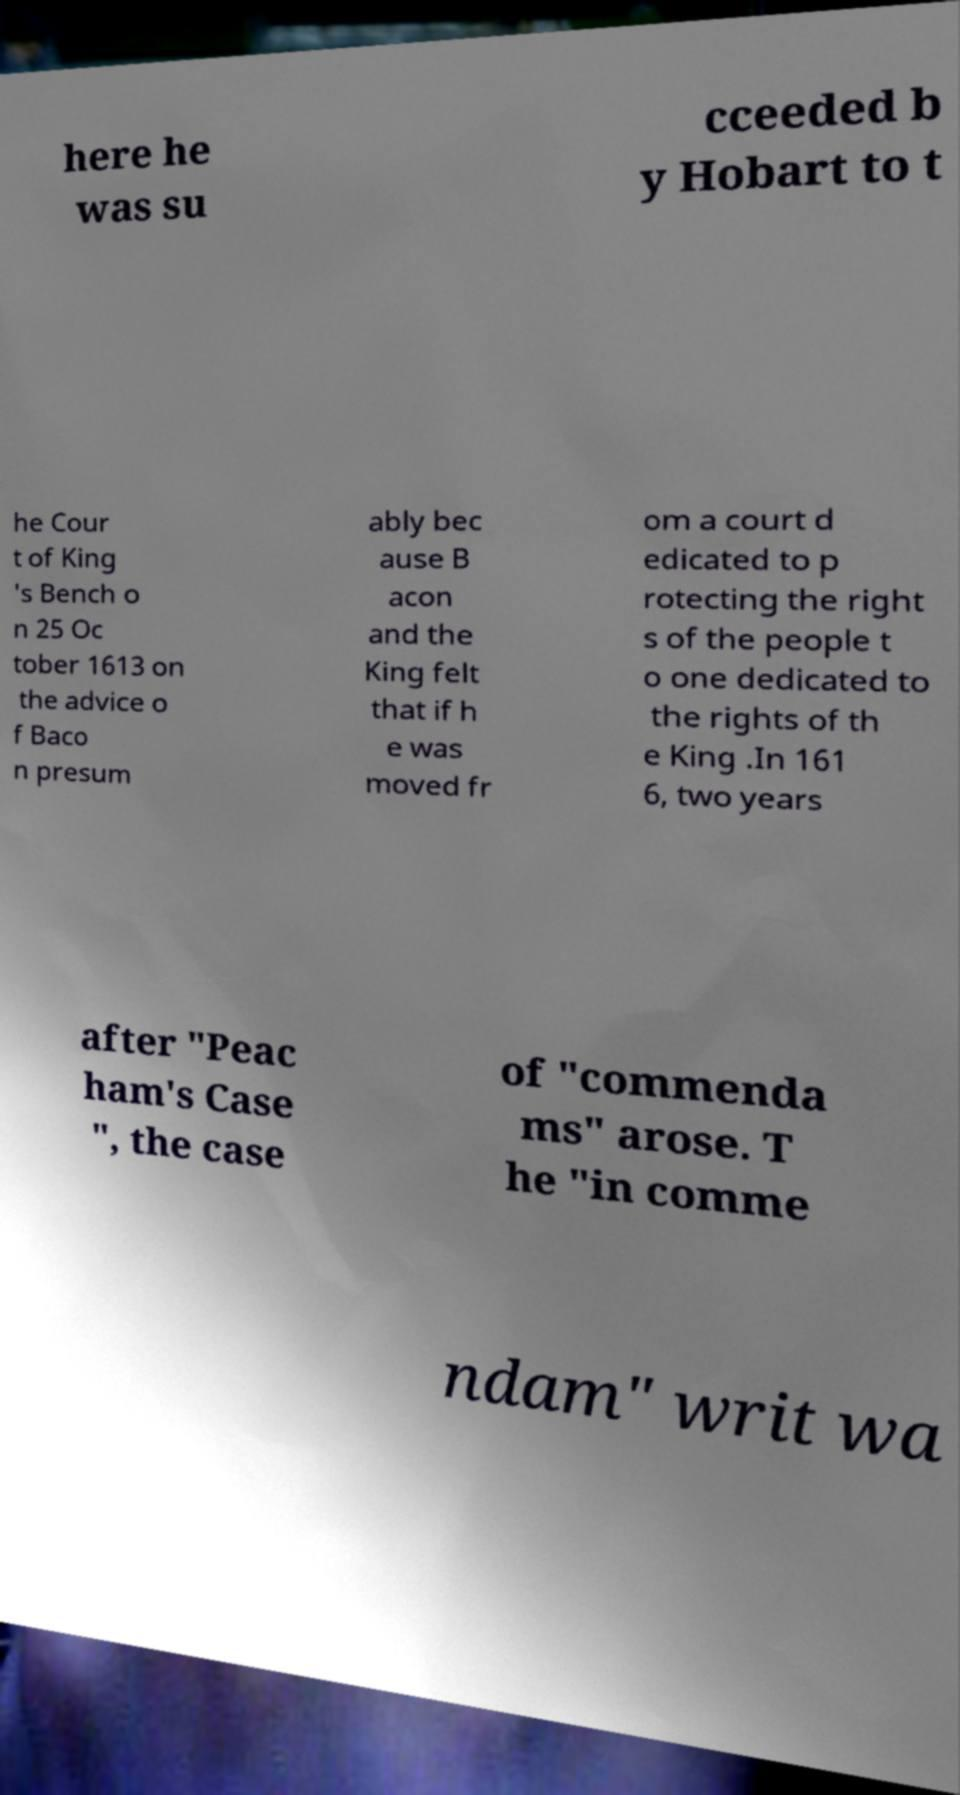I need the written content from this picture converted into text. Can you do that? here he was su cceeded b y Hobart to t he Cour t of King 's Bench o n 25 Oc tober 1613 on the advice o f Baco n presum ably bec ause B acon and the King felt that if h e was moved fr om a court d edicated to p rotecting the right s of the people t o one dedicated to the rights of th e King .In 161 6, two years after "Peac ham's Case ", the case of "commenda ms" arose. T he "in comme ndam" writ wa 